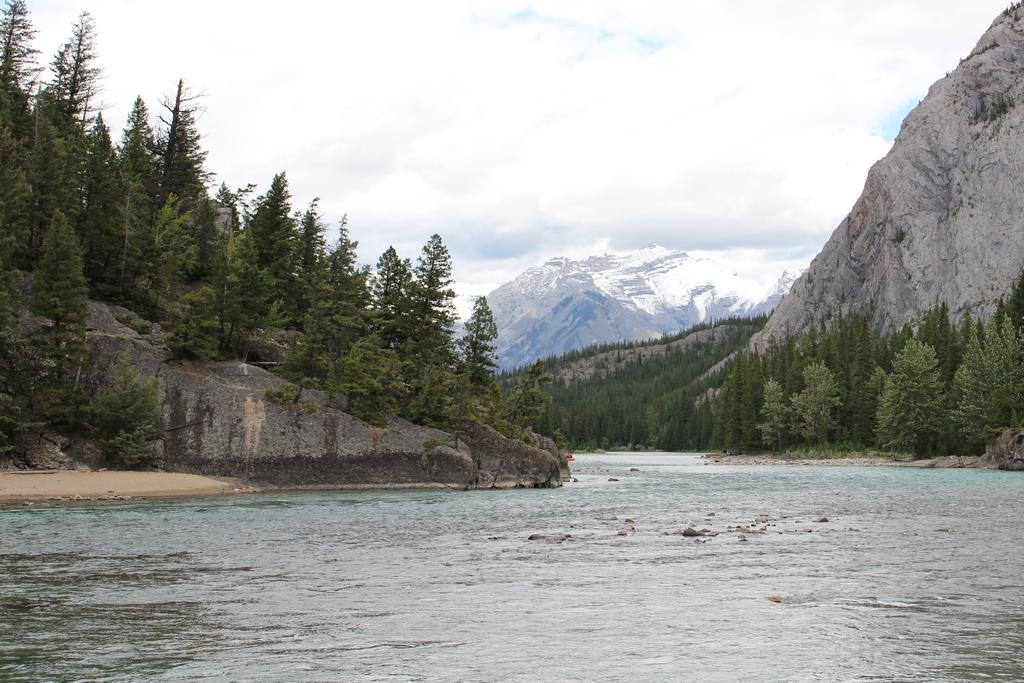What is present in the front of the image? There is water in the front of the image. What can be seen in the background of the image? There are trees and mountains in the background of the image. How would you describe the sky in the image? The sky is cloudy in the image. What type of calculator can be seen in the image? There is no calculator present in the image. What is the motion of the trees in the image? The trees are not in motion in the image; they are stationary. 